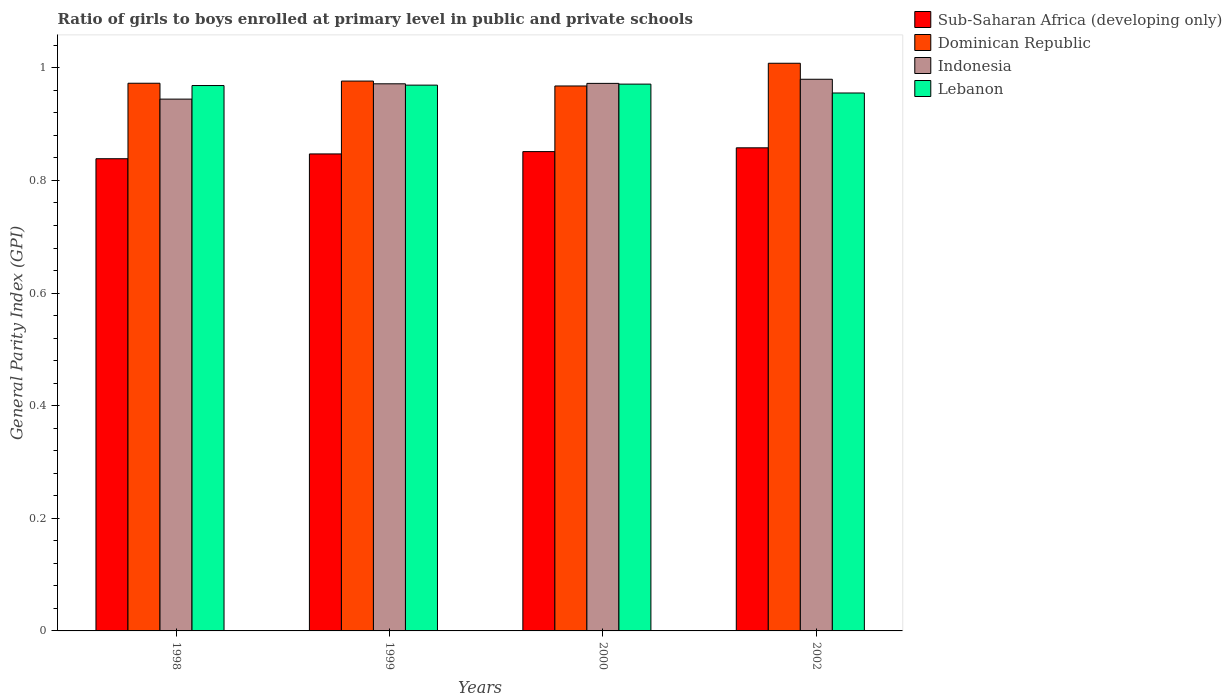Are the number of bars per tick equal to the number of legend labels?
Ensure brevity in your answer.  Yes. Are the number of bars on each tick of the X-axis equal?
Give a very brief answer. Yes. What is the label of the 3rd group of bars from the left?
Your answer should be very brief. 2000. In how many cases, is the number of bars for a given year not equal to the number of legend labels?
Your answer should be compact. 0. What is the general parity index in Dominican Republic in 1999?
Your answer should be compact. 0.98. Across all years, what is the maximum general parity index in Sub-Saharan Africa (developing only)?
Offer a terse response. 0.86. Across all years, what is the minimum general parity index in Sub-Saharan Africa (developing only)?
Your response must be concise. 0.84. In which year was the general parity index in Dominican Republic minimum?
Keep it short and to the point. 2000. What is the total general parity index in Dominican Republic in the graph?
Give a very brief answer. 3.92. What is the difference between the general parity index in Sub-Saharan Africa (developing only) in 2000 and that in 2002?
Your answer should be very brief. -0.01. What is the difference between the general parity index in Dominican Republic in 1998 and the general parity index in Indonesia in 2002?
Offer a very short reply. -0.01. What is the average general parity index in Dominican Republic per year?
Your answer should be very brief. 0.98. In the year 2000, what is the difference between the general parity index in Lebanon and general parity index in Sub-Saharan Africa (developing only)?
Keep it short and to the point. 0.12. What is the ratio of the general parity index in Dominican Republic in 1999 to that in 2002?
Keep it short and to the point. 0.97. Is the general parity index in Indonesia in 1999 less than that in 2002?
Offer a terse response. Yes. What is the difference between the highest and the second highest general parity index in Indonesia?
Your response must be concise. 0.01. What is the difference between the highest and the lowest general parity index in Lebanon?
Your response must be concise. 0.02. In how many years, is the general parity index in Lebanon greater than the average general parity index in Lebanon taken over all years?
Offer a terse response. 3. Is it the case that in every year, the sum of the general parity index in Indonesia and general parity index in Lebanon is greater than the sum of general parity index in Dominican Republic and general parity index in Sub-Saharan Africa (developing only)?
Provide a succinct answer. Yes. What does the 4th bar from the left in 2002 represents?
Offer a very short reply. Lebanon. What does the 1st bar from the right in 1998 represents?
Your answer should be compact. Lebanon. Is it the case that in every year, the sum of the general parity index in Lebanon and general parity index in Sub-Saharan Africa (developing only) is greater than the general parity index in Indonesia?
Make the answer very short. Yes. Are all the bars in the graph horizontal?
Provide a short and direct response. No. What is the difference between two consecutive major ticks on the Y-axis?
Offer a terse response. 0.2. Where does the legend appear in the graph?
Keep it short and to the point. Top right. How are the legend labels stacked?
Make the answer very short. Vertical. What is the title of the graph?
Keep it short and to the point. Ratio of girls to boys enrolled at primary level in public and private schools. What is the label or title of the Y-axis?
Give a very brief answer. General Parity Index (GPI). What is the General Parity Index (GPI) of Sub-Saharan Africa (developing only) in 1998?
Give a very brief answer. 0.84. What is the General Parity Index (GPI) in Dominican Republic in 1998?
Your answer should be compact. 0.97. What is the General Parity Index (GPI) of Indonesia in 1998?
Your answer should be very brief. 0.94. What is the General Parity Index (GPI) of Lebanon in 1998?
Keep it short and to the point. 0.97. What is the General Parity Index (GPI) in Sub-Saharan Africa (developing only) in 1999?
Keep it short and to the point. 0.85. What is the General Parity Index (GPI) in Dominican Republic in 1999?
Give a very brief answer. 0.98. What is the General Parity Index (GPI) of Indonesia in 1999?
Keep it short and to the point. 0.97. What is the General Parity Index (GPI) of Lebanon in 1999?
Provide a succinct answer. 0.97. What is the General Parity Index (GPI) of Sub-Saharan Africa (developing only) in 2000?
Offer a very short reply. 0.85. What is the General Parity Index (GPI) in Dominican Republic in 2000?
Ensure brevity in your answer.  0.97. What is the General Parity Index (GPI) in Indonesia in 2000?
Your answer should be compact. 0.97. What is the General Parity Index (GPI) of Lebanon in 2000?
Provide a short and direct response. 0.97. What is the General Parity Index (GPI) of Sub-Saharan Africa (developing only) in 2002?
Your answer should be compact. 0.86. What is the General Parity Index (GPI) of Dominican Republic in 2002?
Provide a short and direct response. 1.01. What is the General Parity Index (GPI) in Indonesia in 2002?
Your answer should be compact. 0.98. What is the General Parity Index (GPI) in Lebanon in 2002?
Provide a succinct answer. 0.96. Across all years, what is the maximum General Parity Index (GPI) in Sub-Saharan Africa (developing only)?
Your response must be concise. 0.86. Across all years, what is the maximum General Parity Index (GPI) of Dominican Republic?
Your response must be concise. 1.01. Across all years, what is the maximum General Parity Index (GPI) of Indonesia?
Ensure brevity in your answer.  0.98. Across all years, what is the maximum General Parity Index (GPI) in Lebanon?
Your answer should be compact. 0.97. Across all years, what is the minimum General Parity Index (GPI) in Sub-Saharan Africa (developing only)?
Give a very brief answer. 0.84. Across all years, what is the minimum General Parity Index (GPI) in Dominican Republic?
Give a very brief answer. 0.97. Across all years, what is the minimum General Parity Index (GPI) of Indonesia?
Your answer should be very brief. 0.94. Across all years, what is the minimum General Parity Index (GPI) in Lebanon?
Your answer should be very brief. 0.96. What is the total General Parity Index (GPI) of Sub-Saharan Africa (developing only) in the graph?
Provide a short and direct response. 3.39. What is the total General Parity Index (GPI) of Dominican Republic in the graph?
Offer a terse response. 3.92. What is the total General Parity Index (GPI) in Indonesia in the graph?
Make the answer very short. 3.87. What is the total General Parity Index (GPI) in Lebanon in the graph?
Keep it short and to the point. 3.86. What is the difference between the General Parity Index (GPI) of Sub-Saharan Africa (developing only) in 1998 and that in 1999?
Ensure brevity in your answer.  -0.01. What is the difference between the General Parity Index (GPI) of Dominican Republic in 1998 and that in 1999?
Ensure brevity in your answer.  -0. What is the difference between the General Parity Index (GPI) of Indonesia in 1998 and that in 1999?
Offer a very short reply. -0.03. What is the difference between the General Parity Index (GPI) of Lebanon in 1998 and that in 1999?
Ensure brevity in your answer.  -0. What is the difference between the General Parity Index (GPI) of Sub-Saharan Africa (developing only) in 1998 and that in 2000?
Provide a succinct answer. -0.01. What is the difference between the General Parity Index (GPI) in Dominican Republic in 1998 and that in 2000?
Ensure brevity in your answer.  0. What is the difference between the General Parity Index (GPI) of Indonesia in 1998 and that in 2000?
Your answer should be compact. -0.03. What is the difference between the General Parity Index (GPI) of Lebanon in 1998 and that in 2000?
Your answer should be very brief. -0. What is the difference between the General Parity Index (GPI) in Sub-Saharan Africa (developing only) in 1998 and that in 2002?
Make the answer very short. -0.02. What is the difference between the General Parity Index (GPI) in Dominican Republic in 1998 and that in 2002?
Offer a terse response. -0.04. What is the difference between the General Parity Index (GPI) in Indonesia in 1998 and that in 2002?
Offer a very short reply. -0.04. What is the difference between the General Parity Index (GPI) of Lebanon in 1998 and that in 2002?
Keep it short and to the point. 0.01. What is the difference between the General Parity Index (GPI) in Sub-Saharan Africa (developing only) in 1999 and that in 2000?
Your answer should be very brief. -0. What is the difference between the General Parity Index (GPI) of Dominican Republic in 1999 and that in 2000?
Provide a succinct answer. 0.01. What is the difference between the General Parity Index (GPI) of Indonesia in 1999 and that in 2000?
Provide a short and direct response. -0. What is the difference between the General Parity Index (GPI) of Lebanon in 1999 and that in 2000?
Give a very brief answer. -0. What is the difference between the General Parity Index (GPI) in Sub-Saharan Africa (developing only) in 1999 and that in 2002?
Your answer should be very brief. -0.01. What is the difference between the General Parity Index (GPI) of Dominican Republic in 1999 and that in 2002?
Your answer should be compact. -0.03. What is the difference between the General Parity Index (GPI) of Indonesia in 1999 and that in 2002?
Provide a short and direct response. -0.01. What is the difference between the General Parity Index (GPI) of Lebanon in 1999 and that in 2002?
Provide a succinct answer. 0.01. What is the difference between the General Parity Index (GPI) in Sub-Saharan Africa (developing only) in 2000 and that in 2002?
Give a very brief answer. -0.01. What is the difference between the General Parity Index (GPI) in Dominican Republic in 2000 and that in 2002?
Make the answer very short. -0.04. What is the difference between the General Parity Index (GPI) in Indonesia in 2000 and that in 2002?
Ensure brevity in your answer.  -0.01. What is the difference between the General Parity Index (GPI) in Lebanon in 2000 and that in 2002?
Offer a very short reply. 0.02. What is the difference between the General Parity Index (GPI) in Sub-Saharan Africa (developing only) in 1998 and the General Parity Index (GPI) in Dominican Republic in 1999?
Your answer should be very brief. -0.14. What is the difference between the General Parity Index (GPI) in Sub-Saharan Africa (developing only) in 1998 and the General Parity Index (GPI) in Indonesia in 1999?
Offer a very short reply. -0.13. What is the difference between the General Parity Index (GPI) of Sub-Saharan Africa (developing only) in 1998 and the General Parity Index (GPI) of Lebanon in 1999?
Provide a succinct answer. -0.13. What is the difference between the General Parity Index (GPI) in Dominican Republic in 1998 and the General Parity Index (GPI) in Indonesia in 1999?
Your answer should be very brief. 0. What is the difference between the General Parity Index (GPI) of Dominican Republic in 1998 and the General Parity Index (GPI) of Lebanon in 1999?
Provide a short and direct response. 0. What is the difference between the General Parity Index (GPI) of Indonesia in 1998 and the General Parity Index (GPI) of Lebanon in 1999?
Give a very brief answer. -0.02. What is the difference between the General Parity Index (GPI) of Sub-Saharan Africa (developing only) in 1998 and the General Parity Index (GPI) of Dominican Republic in 2000?
Offer a terse response. -0.13. What is the difference between the General Parity Index (GPI) in Sub-Saharan Africa (developing only) in 1998 and the General Parity Index (GPI) in Indonesia in 2000?
Provide a succinct answer. -0.13. What is the difference between the General Parity Index (GPI) of Sub-Saharan Africa (developing only) in 1998 and the General Parity Index (GPI) of Lebanon in 2000?
Your answer should be very brief. -0.13. What is the difference between the General Parity Index (GPI) of Dominican Republic in 1998 and the General Parity Index (GPI) of Indonesia in 2000?
Your response must be concise. 0. What is the difference between the General Parity Index (GPI) of Dominican Republic in 1998 and the General Parity Index (GPI) of Lebanon in 2000?
Keep it short and to the point. 0. What is the difference between the General Parity Index (GPI) in Indonesia in 1998 and the General Parity Index (GPI) in Lebanon in 2000?
Provide a succinct answer. -0.03. What is the difference between the General Parity Index (GPI) of Sub-Saharan Africa (developing only) in 1998 and the General Parity Index (GPI) of Dominican Republic in 2002?
Your response must be concise. -0.17. What is the difference between the General Parity Index (GPI) of Sub-Saharan Africa (developing only) in 1998 and the General Parity Index (GPI) of Indonesia in 2002?
Provide a succinct answer. -0.14. What is the difference between the General Parity Index (GPI) in Sub-Saharan Africa (developing only) in 1998 and the General Parity Index (GPI) in Lebanon in 2002?
Your response must be concise. -0.12. What is the difference between the General Parity Index (GPI) in Dominican Republic in 1998 and the General Parity Index (GPI) in Indonesia in 2002?
Your answer should be very brief. -0.01. What is the difference between the General Parity Index (GPI) in Dominican Republic in 1998 and the General Parity Index (GPI) in Lebanon in 2002?
Make the answer very short. 0.02. What is the difference between the General Parity Index (GPI) of Indonesia in 1998 and the General Parity Index (GPI) of Lebanon in 2002?
Keep it short and to the point. -0.01. What is the difference between the General Parity Index (GPI) of Sub-Saharan Africa (developing only) in 1999 and the General Parity Index (GPI) of Dominican Republic in 2000?
Make the answer very short. -0.12. What is the difference between the General Parity Index (GPI) in Sub-Saharan Africa (developing only) in 1999 and the General Parity Index (GPI) in Indonesia in 2000?
Ensure brevity in your answer.  -0.13. What is the difference between the General Parity Index (GPI) in Sub-Saharan Africa (developing only) in 1999 and the General Parity Index (GPI) in Lebanon in 2000?
Your answer should be compact. -0.12. What is the difference between the General Parity Index (GPI) of Dominican Republic in 1999 and the General Parity Index (GPI) of Indonesia in 2000?
Provide a short and direct response. 0. What is the difference between the General Parity Index (GPI) in Dominican Republic in 1999 and the General Parity Index (GPI) in Lebanon in 2000?
Keep it short and to the point. 0.01. What is the difference between the General Parity Index (GPI) of Indonesia in 1999 and the General Parity Index (GPI) of Lebanon in 2000?
Ensure brevity in your answer.  0. What is the difference between the General Parity Index (GPI) of Sub-Saharan Africa (developing only) in 1999 and the General Parity Index (GPI) of Dominican Republic in 2002?
Give a very brief answer. -0.16. What is the difference between the General Parity Index (GPI) of Sub-Saharan Africa (developing only) in 1999 and the General Parity Index (GPI) of Indonesia in 2002?
Provide a succinct answer. -0.13. What is the difference between the General Parity Index (GPI) in Sub-Saharan Africa (developing only) in 1999 and the General Parity Index (GPI) in Lebanon in 2002?
Give a very brief answer. -0.11. What is the difference between the General Parity Index (GPI) in Dominican Republic in 1999 and the General Parity Index (GPI) in Indonesia in 2002?
Your response must be concise. -0. What is the difference between the General Parity Index (GPI) in Dominican Republic in 1999 and the General Parity Index (GPI) in Lebanon in 2002?
Make the answer very short. 0.02. What is the difference between the General Parity Index (GPI) in Indonesia in 1999 and the General Parity Index (GPI) in Lebanon in 2002?
Provide a short and direct response. 0.02. What is the difference between the General Parity Index (GPI) of Sub-Saharan Africa (developing only) in 2000 and the General Parity Index (GPI) of Dominican Republic in 2002?
Your answer should be very brief. -0.16. What is the difference between the General Parity Index (GPI) of Sub-Saharan Africa (developing only) in 2000 and the General Parity Index (GPI) of Indonesia in 2002?
Provide a short and direct response. -0.13. What is the difference between the General Parity Index (GPI) of Sub-Saharan Africa (developing only) in 2000 and the General Parity Index (GPI) of Lebanon in 2002?
Offer a terse response. -0.1. What is the difference between the General Parity Index (GPI) of Dominican Republic in 2000 and the General Parity Index (GPI) of Indonesia in 2002?
Give a very brief answer. -0.01. What is the difference between the General Parity Index (GPI) of Dominican Republic in 2000 and the General Parity Index (GPI) of Lebanon in 2002?
Offer a terse response. 0.01. What is the difference between the General Parity Index (GPI) of Indonesia in 2000 and the General Parity Index (GPI) of Lebanon in 2002?
Your answer should be very brief. 0.02. What is the average General Parity Index (GPI) in Sub-Saharan Africa (developing only) per year?
Provide a succinct answer. 0.85. What is the average General Parity Index (GPI) of Dominican Republic per year?
Offer a terse response. 0.98. What is the average General Parity Index (GPI) of Indonesia per year?
Provide a short and direct response. 0.97. What is the average General Parity Index (GPI) of Lebanon per year?
Provide a short and direct response. 0.97. In the year 1998, what is the difference between the General Parity Index (GPI) of Sub-Saharan Africa (developing only) and General Parity Index (GPI) of Dominican Republic?
Give a very brief answer. -0.13. In the year 1998, what is the difference between the General Parity Index (GPI) of Sub-Saharan Africa (developing only) and General Parity Index (GPI) of Indonesia?
Make the answer very short. -0.11. In the year 1998, what is the difference between the General Parity Index (GPI) of Sub-Saharan Africa (developing only) and General Parity Index (GPI) of Lebanon?
Offer a terse response. -0.13. In the year 1998, what is the difference between the General Parity Index (GPI) in Dominican Republic and General Parity Index (GPI) in Indonesia?
Your answer should be very brief. 0.03. In the year 1998, what is the difference between the General Parity Index (GPI) of Dominican Republic and General Parity Index (GPI) of Lebanon?
Your response must be concise. 0. In the year 1998, what is the difference between the General Parity Index (GPI) in Indonesia and General Parity Index (GPI) in Lebanon?
Your response must be concise. -0.02. In the year 1999, what is the difference between the General Parity Index (GPI) of Sub-Saharan Africa (developing only) and General Parity Index (GPI) of Dominican Republic?
Offer a very short reply. -0.13. In the year 1999, what is the difference between the General Parity Index (GPI) of Sub-Saharan Africa (developing only) and General Parity Index (GPI) of Indonesia?
Provide a succinct answer. -0.12. In the year 1999, what is the difference between the General Parity Index (GPI) in Sub-Saharan Africa (developing only) and General Parity Index (GPI) in Lebanon?
Provide a succinct answer. -0.12. In the year 1999, what is the difference between the General Parity Index (GPI) of Dominican Republic and General Parity Index (GPI) of Indonesia?
Your answer should be very brief. 0. In the year 1999, what is the difference between the General Parity Index (GPI) in Dominican Republic and General Parity Index (GPI) in Lebanon?
Give a very brief answer. 0.01. In the year 1999, what is the difference between the General Parity Index (GPI) in Indonesia and General Parity Index (GPI) in Lebanon?
Your response must be concise. 0. In the year 2000, what is the difference between the General Parity Index (GPI) in Sub-Saharan Africa (developing only) and General Parity Index (GPI) in Dominican Republic?
Make the answer very short. -0.12. In the year 2000, what is the difference between the General Parity Index (GPI) in Sub-Saharan Africa (developing only) and General Parity Index (GPI) in Indonesia?
Your answer should be compact. -0.12. In the year 2000, what is the difference between the General Parity Index (GPI) in Sub-Saharan Africa (developing only) and General Parity Index (GPI) in Lebanon?
Make the answer very short. -0.12. In the year 2000, what is the difference between the General Parity Index (GPI) in Dominican Republic and General Parity Index (GPI) in Indonesia?
Make the answer very short. -0. In the year 2000, what is the difference between the General Parity Index (GPI) in Dominican Republic and General Parity Index (GPI) in Lebanon?
Your response must be concise. -0. In the year 2000, what is the difference between the General Parity Index (GPI) in Indonesia and General Parity Index (GPI) in Lebanon?
Your answer should be compact. 0. In the year 2002, what is the difference between the General Parity Index (GPI) of Sub-Saharan Africa (developing only) and General Parity Index (GPI) of Dominican Republic?
Keep it short and to the point. -0.15. In the year 2002, what is the difference between the General Parity Index (GPI) in Sub-Saharan Africa (developing only) and General Parity Index (GPI) in Indonesia?
Provide a short and direct response. -0.12. In the year 2002, what is the difference between the General Parity Index (GPI) of Sub-Saharan Africa (developing only) and General Parity Index (GPI) of Lebanon?
Offer a very short reply. -0.1. In the year 2002, what is the difference between the General Parity Index (GPI) in Dominican Republic and General Parity Index (GPI) in Indonesia?
Your answer should be compact. 0.03. In the year 2002, what is the difference between the General Parity Index (GPI) of Dominican Republic and General Parity Index (GPI) of Lebanon?
Ensure brevity in your answer.  0.05. In the year 2002, what is the difference between the General Parity Index (GPI) of Indonesia and General Parity Index (GPI) of Lebanon?
Your answer should be very brief. 0.02. What is the ratio of the General Parity Index (GPI) in Sub-Saharan Africa (developing only) in 1998 to that in 1999?
Your response must be concise. 0.99. What is the ratio of the General Parity Index (GPI) of Indonesia in 1998 to that in 1999?
Provide a short and direct response. 0.97. What is the ratio of the General Parity Index (GPI) of Lebanon in 1998 to that in 1999?
Offer a very short reply. 1. What is the ratio of the General Parity Index (GPI) of Sub-Saharan Africa (developing only) in 1998 to that in 2000?
Provide a succinct answer. 0.99. What is the ratio of the General Parity Index (GPI) of Dominican Republic in 1998 to that in 2000?
Provide a short and direct response. 1. What is the ratio of the General Parity Index (GPI) in Indonesia in 1998 to that in 2000?
Offer a terse response. 0.97. What is the ratio of the General Parity Index (GPI) of Lebanon in 1998 to that in 2000?
Keep it short and to the point. 1. What is the ratio of the General Parity Index (GPI) of Sub-Saharan Africa (developing only) in 1998 to that in 2002?
Give a very brief answer. 0.98. What is the ratio of the General Parity Index (GPI) in Dominican Republic in 1998 to that in 2002?
Your answer should be very brief. 0.96. What is the ratio of the General Parity Index (GPI) in Indonesia in 1998 to that in 2002?
Ensure brevity in your answer.  0.96. What is the ratio of the General Parity Index (GPI) of Lebanon in 1998 to that in 2002?
Your answer should be very brief. 1.01. What is the ratio of the General Parity Index (GPI) in Sub-Saharan Africa (developing only) in 1999 to that in 2000?
Provide a short and direct response. 1. What is the ratio of the General Parity Index (GPI) of Dominican Republic in 1999 to that in 2000?
Keep it short and to the point. 1.01. What is the ratio of the General Parity Index (GPI) in Indonesia in 1999 to that in 2000?
Offer a terse response. 1. What is the ratio of the General Parity Index (GPI) in Lebanon in 1999 to that in 2000?
Provide a short and direct response. 1. What is the ratio of the General Parity Index (GPI) of Sub-Saharan Africa (developing only) in 1999 to that in 2002?
Give a very brief answer. 0.99. What is the ratio of the General Parity Index (GPI) in Dominican Republic in 1999 to that in 2002?
Make the answer very short. 0.97. What is the ratio of the General Parity Index (GPI) of Indonesia in 1999 to that in 2002?
Offer a very short reply. 0.99. What is the ratio of the General Parity Index (GPI) in Lebanon in 1999 to that in 2002?
Make the answer very short. 1.01. What is the ratio of the General Parity Index (GPI) of Sub-Saharan Africa (developing only) in 2000 to that in 2002?
Offer a terse response. 0.99. What is the ratio of the General Parity Index (GPI) in Dominican Republic in 2000 to that in 2002?
Offer a very short reply. 0.96. What is the ratio of the General Parity Index (GPI) in Indonesia in 2000 to that in 2002?
Your response must be concise. 0.99. What is the ratio of the General Parity Index (GPI) in Lebanon in 2000 to that in 2002?
Ensure brevity in your answer.  1.02. What is the difference between the highest and the second highest General Parity Index (GPI) in Sub-Saharan Africa (developing only)?
Offer a terse response. 0.01. What is the difference between the highest and the second highest General Parity Index (GPI) in Dominican Republic?
Your response must be concise. 0.03. What is the difference between the highest and the second highest General Parity Index (GPI) of Indonesia?
Offer a terse response. 0.01. What is the difference between the highest and the second highest General Parity Index (GPI) in Lebanon?
Keep it short and to the point. 0. What is the difference between the highest and the lowest General Parity Index (GPI) of Sub-Saharan Africa (developing only)?
Keep it short and to the point. 0.02. What is the difference between the highest and the lowest General Parity Index (GPI) in Dominican Republic?
Your response must be concise. 0.04. What is the difference between the highest and the lowest General Parity Index (GPI) of Indonesia?
Offer a very short reply. 0.04. What is the difference between the highest and the lowest General Parity Index (GPI) in Lebanon?
Keep it short and to the point. 0.02. 